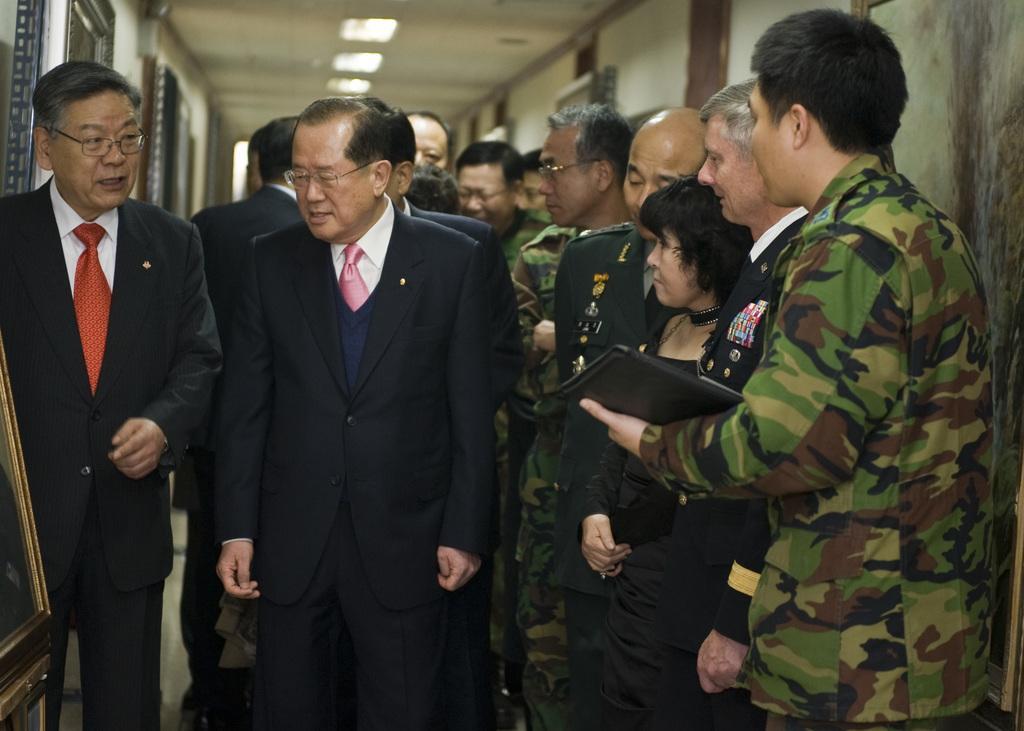How would you summarize this image in a sentence or two? In this image I see number of people in which few of them are wearing suits and few of them are wearing army uniforms and I see that this man is holding a black color thing in his hand and in the background I see the wall and I see lights on the ceiling. 